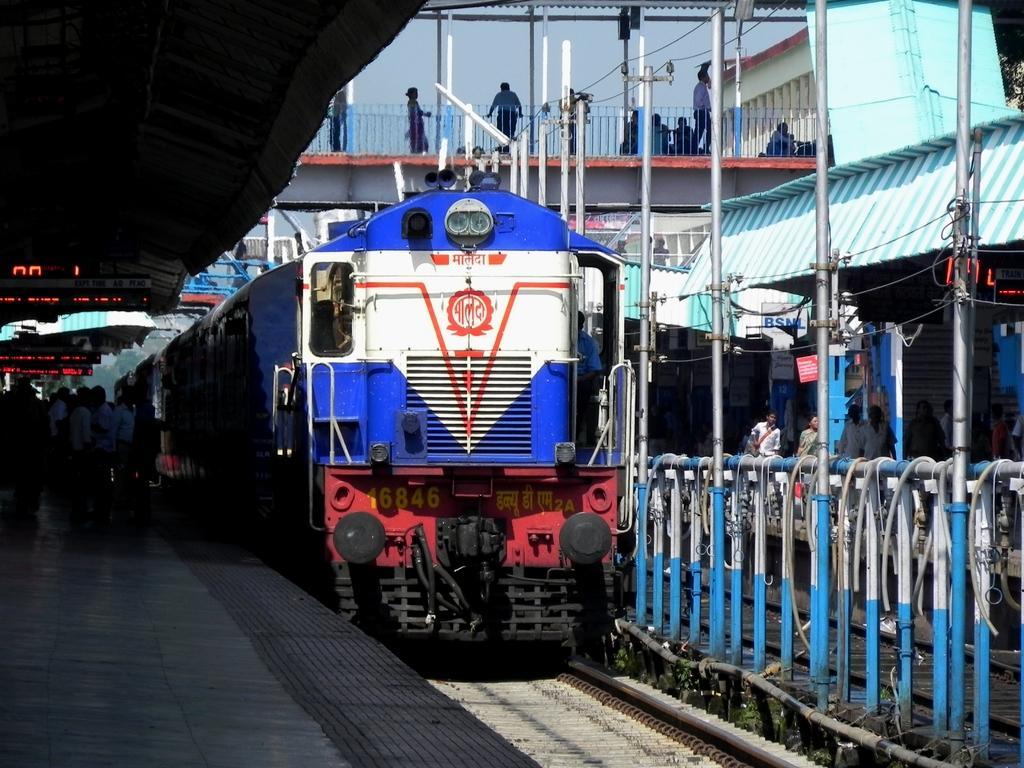Please provide a concise description of this image. In this picture, there is a train in the center which is in blue and red in color. Towards the left, there is a platform with people. Towards the right, there is a fence, poles and a shed. On the top, there is a bridge with people. 